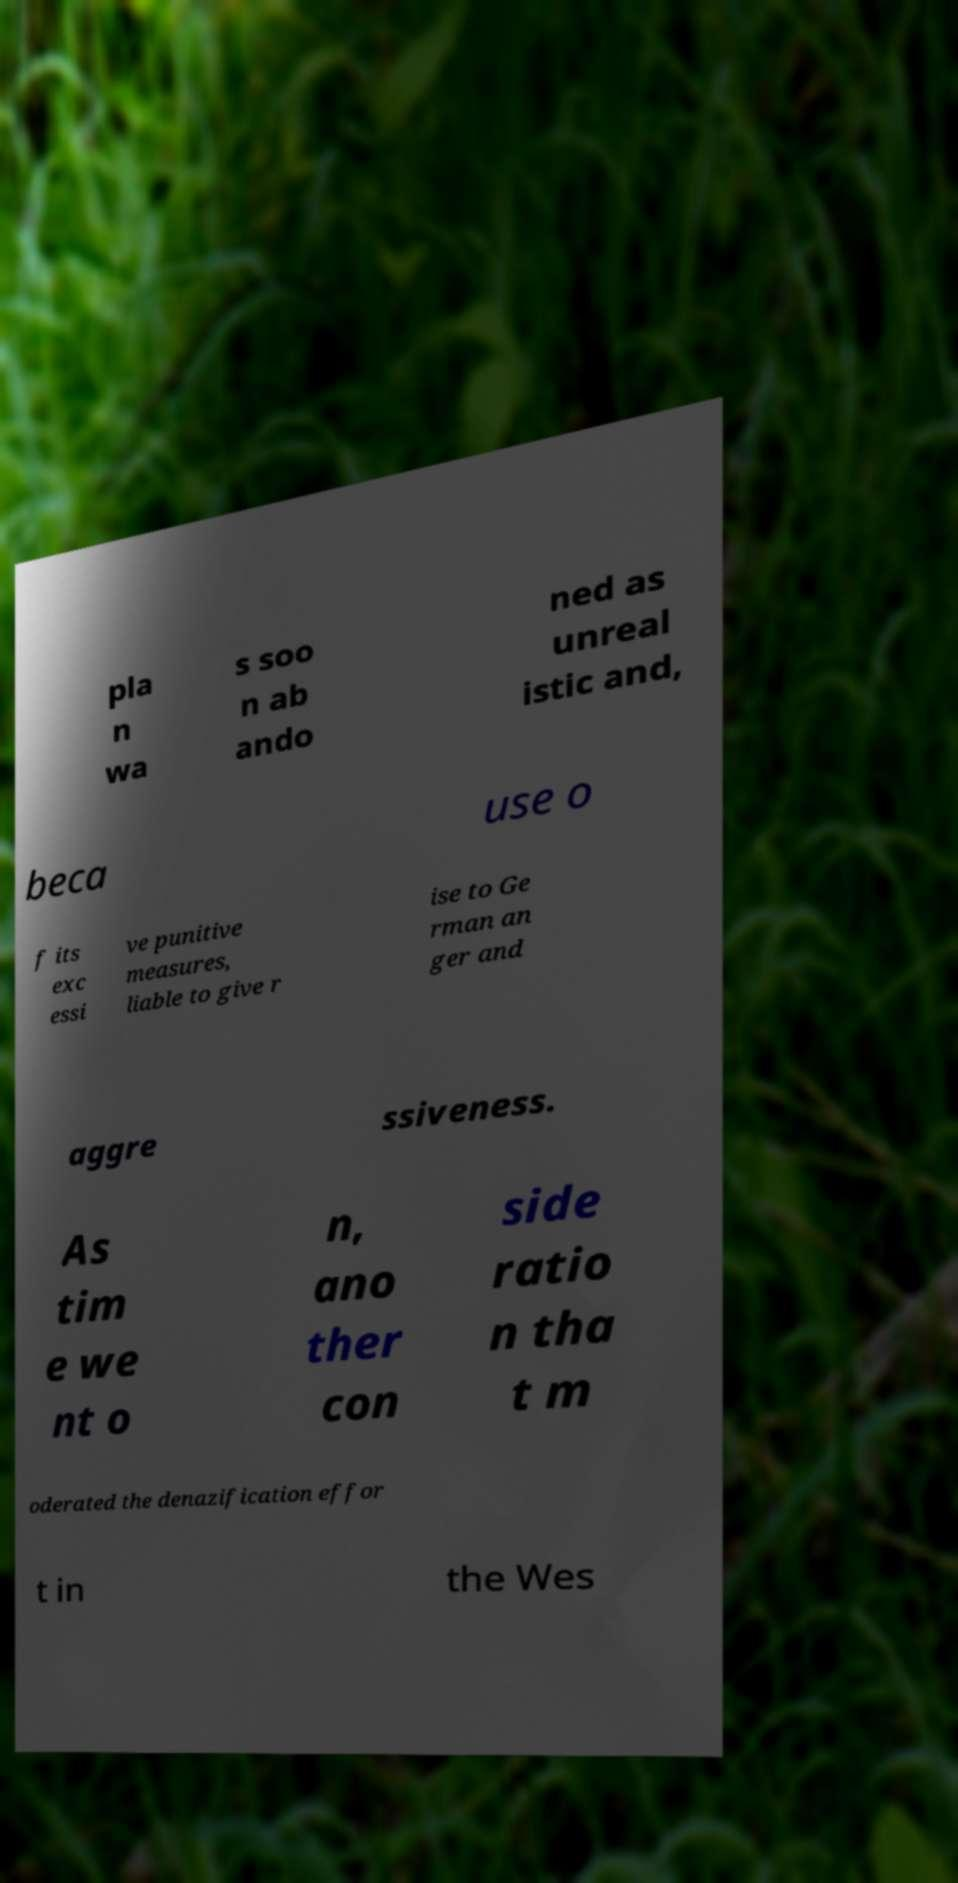Please identify and transcribe the text found in this image. pla n wa s soo n ab ando ned as unreal istic and, beca use o f its exc essi ve punitive measures, liable to give r ise to Ge rman an ger and aggre ssiveness. As tim e we nt o n, ano ther con side ratio n tha t m oderated the denazification effor t in the Wes 